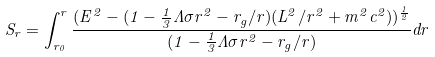<formula> <loc_0><loc_0><loc_500><loc_500>\ S _ { r } = \int _ { r _ { 0 } } ^ { r } \frac { ( E ^ { 2 } - ( 1 - \frac { 1 } { 3 } \Lambda \sigma r ^ { 2 } - r _ { g } / r ) ( L ^ { 2 } / r ^ { 2 } + m ^ { 2 } c ^ { 2 } ) ) ^ { \frac { 1 } { 2 } } } { ( 1 - \frac { 1 } { 3 } \Lambda \sigma r ^ { 2 } - r _ { g } / r ) } d r</formula> 